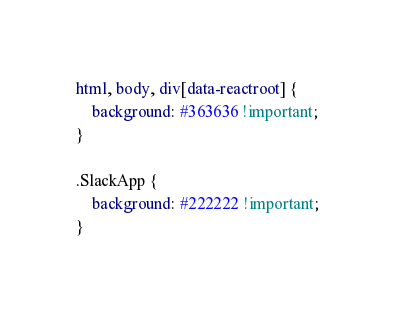Convert code to text. <code><loc_0><loc_0><loc_500><loc_500><_CSS_>html, body, div[data-reactroot] {
    background: #363636 !important;
}

.SlackApp {
    background: #222222 !important;
}
</code> 